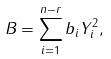<formula> <loc_0><loc_0><loc_500><loc_500>B = \sum _ { i = 1 } ^ { n - r } b _ { i } Y _ { i } ^ { 2 } ,</formula> 